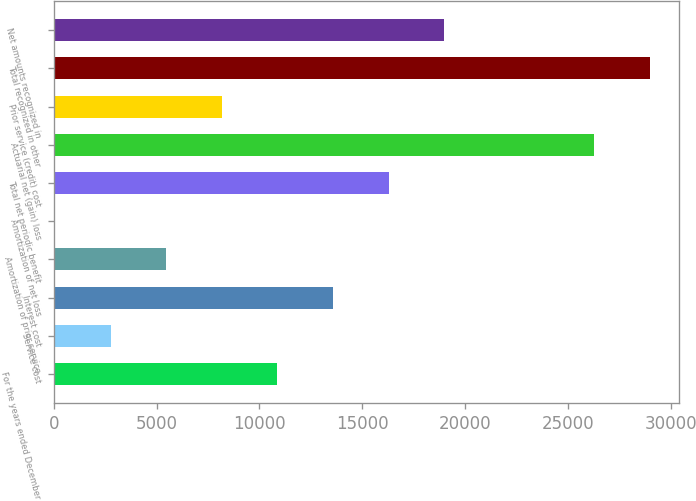Convert chart to OTSL. <chart><loc_0><loc_0><loc_500><loc_500><bar_chart><fcel>For the years ended December<fcel>Service cost<fcel>Interest cost<fcel>Amortization of prior service<fcel>Amortization of net loss<fcel>Total net periodic benefit<fcel>Actuarial net (gain) loss<fcel>Prior service (credit) cost<fcel>Total recognized in other<fcel>Net amounts recognized in<nl><fcel>10875.8<fcel>2761.7<fcel>13580.5<fcel>5466.4<fcel>57<fcel>16285.2<fcel>26270<fcel>8171.1<fcel>28974.7<fcel>18989.9<nl></chart> 